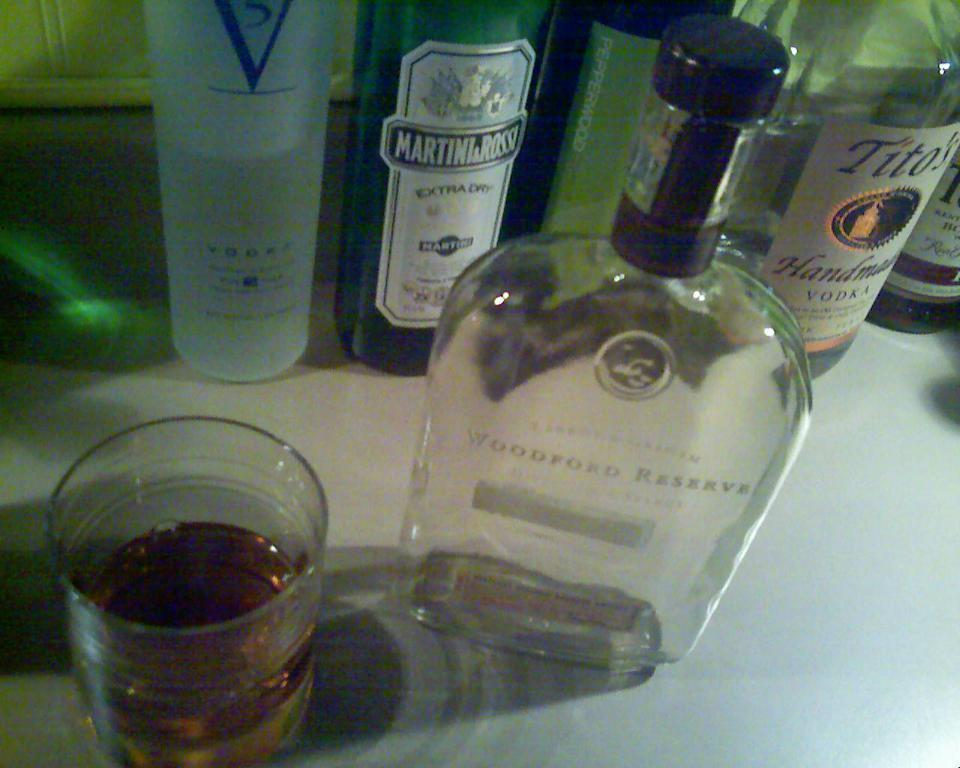Provide a one-sentence caption for the provided image. Some bottles of alcohol, one of which has Extra Dry written on it. 